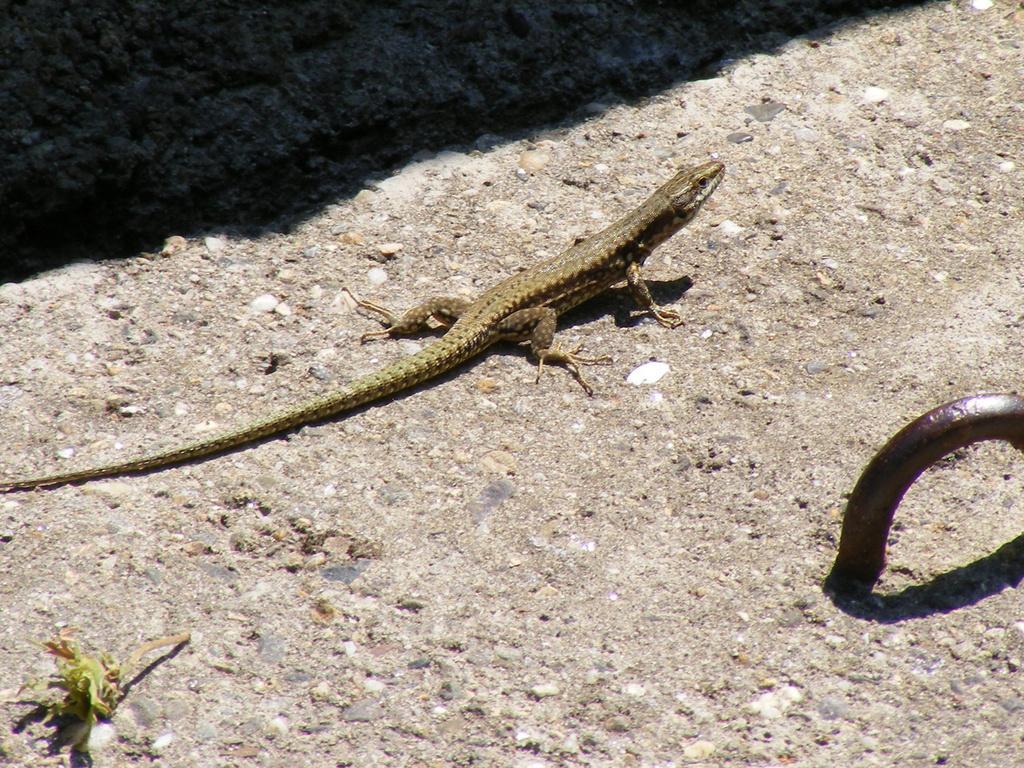Could you give a brief overview of what you see in this image? In this picture we can see reptile on a surface. This is an iron metal object. 